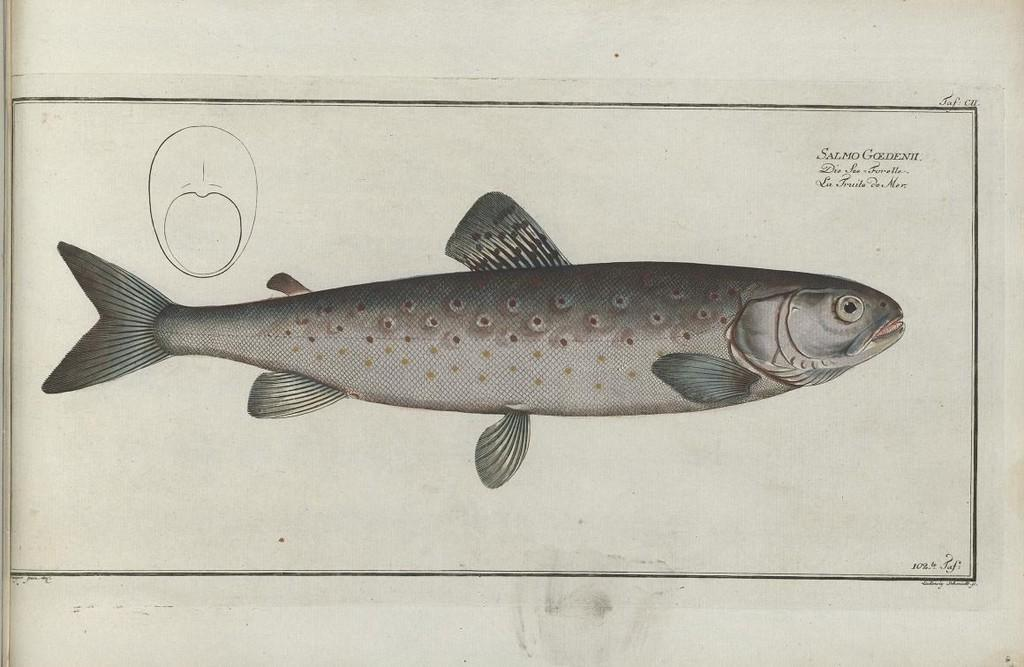What is depicted in the image? There is a drawing of a fish in the image. What else can be found in the image besides the drawing of the fish? There is text in the image. How many units of boots are shown in the image? There are no boots present in the image. What time is displayed on the clocks in the image? There are no clocks present in the image. 